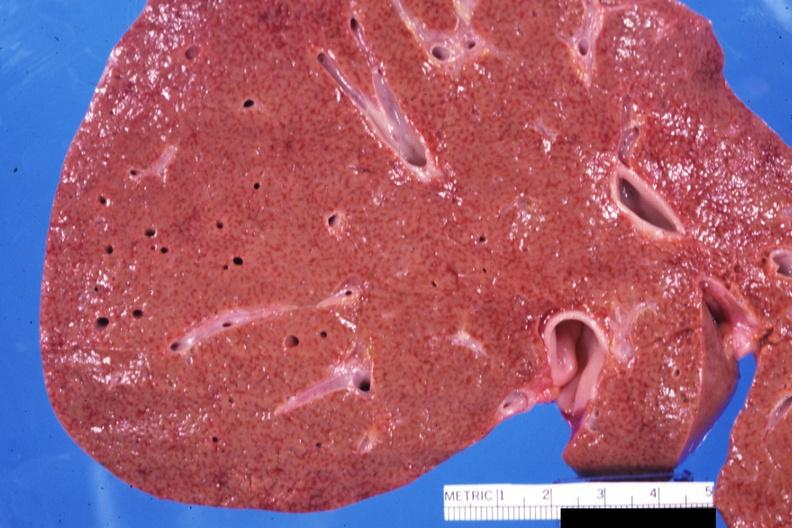does this image show close-up view of early micronodular cirrhosis quite good?
Answer the question using a single word or phrase. Yes 